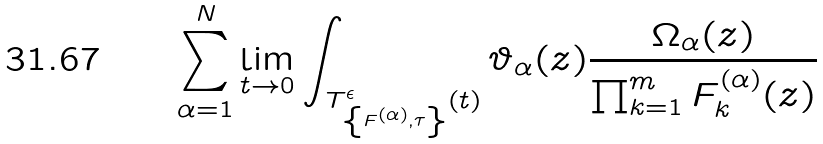Convert formula to latex. <formula><loc_0><loc_0><loc_500><loc_500>\sum _ { \alpha = 1 } ^ { N } \lim _ { t \to 0 } \int _ { T ^ { \epsilon } _ { \left \{ { F } ^ { ( \alpha ) } , \tau \right \} } ( t ) } \vartheta _ { \alpha } ( z ) \frac { \Omega _ { \alpha } ( z ) } { \prod _ { k = 1 } ^ { m } F ^ { ( \alpha ) } _ { k } ( z ) }</formula> 